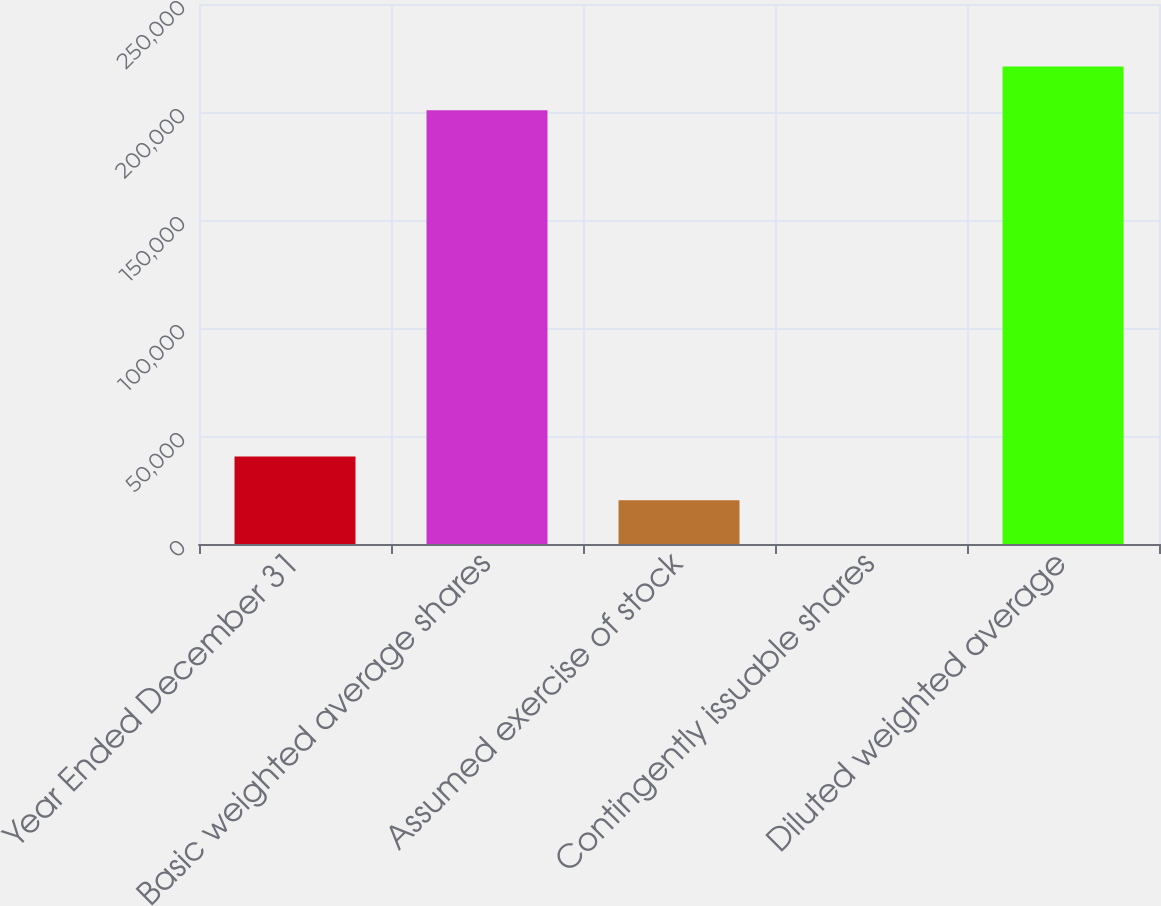Convert chart to OTSL. <chart><loc_0><loc_0><loc_500><loc_500><bar_chart><fcel>Year Ended December 31<fcel>Basic weighted average shares<fcel>Assumed exercise of stock<fcel>Contingently issuable shares<fcel>Diluted weighted average<nl><fcel>40524.8<fcel>200819<fcel>20287.4<fcel>50<fcel>221056<nl></chart> 